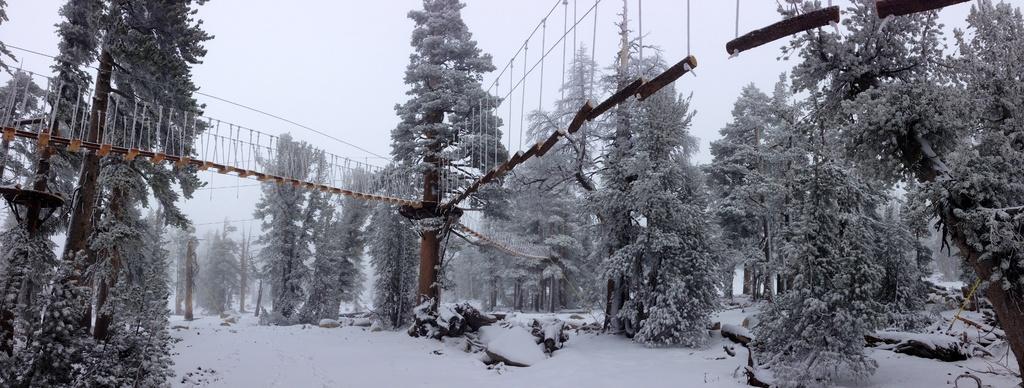Could you give a brief overview of what you see in this image? In this image I can see there are trees , the sky visible, on the tree I can see a bridge attached, there is a snow fall on land. 